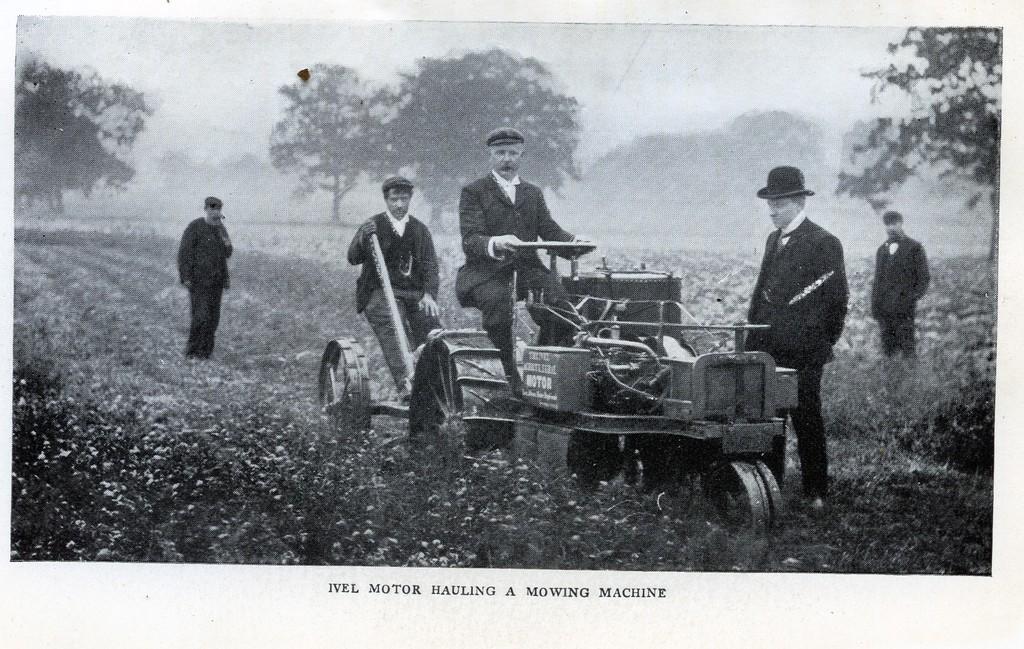Describe this image in one or two sentences. This is a black and white image, in this image in the center there is one vehicle. In the vehicle there are two persons who are sitting, and at the bottom there are some plants. In the background there are some trees, at the bottom of the image there is some text. 